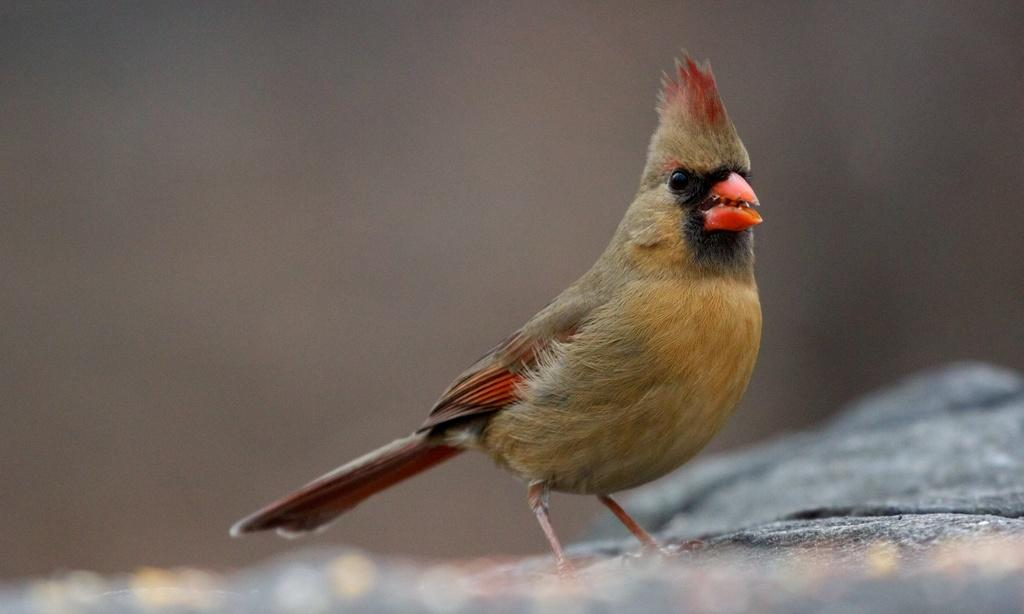What type of animal is present in the image? There is a bird in the image. Can you describe the position of the bird in the image? The bird is standing in the front of the image. How many children are playing in the background of the image? There are no children present in the image; it only features a bird. What type of art is displayed on the bridge in the image? There is no bridge or art present in the image; it only features a bird. 